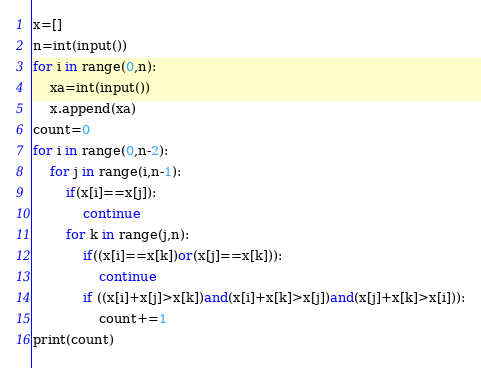Convert code to text. <code><loc_0><loc_0><loc_500><loc_500><_Python_>x=[]
n=int(input())
for i in range(0,n):
    xa=int(input())
    x.append(xa)
count=0
for i in range(0,n-2):
    for j in range(i,n-1):
        if(x[i]==x[j]):
            continue
        for k in range(j,n):
            if((x[i]==x[k])or(x[j]==x[k])):
                continue
            if ((x[i]+x[j]>x[k])and(x[i]+x[k]>x[j])and(x[j]+x[k]>x[i])):
                count+=1
print(count)</code> 